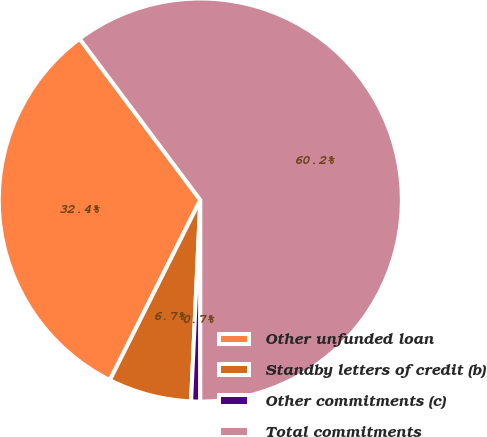Convert chart to OTSL. <chart><loc_0><loc_0><loc_500><loc_500><pie_chart><fcel>Other unfunded loan<fcel>Standby letters of credit (b)<fcel>Other commitments (c)<fcel>Total commitments<nl><fcel>32.37%<fcel>6.68%<fcel>0.73%<fcel>60.23%<nl></chart> 